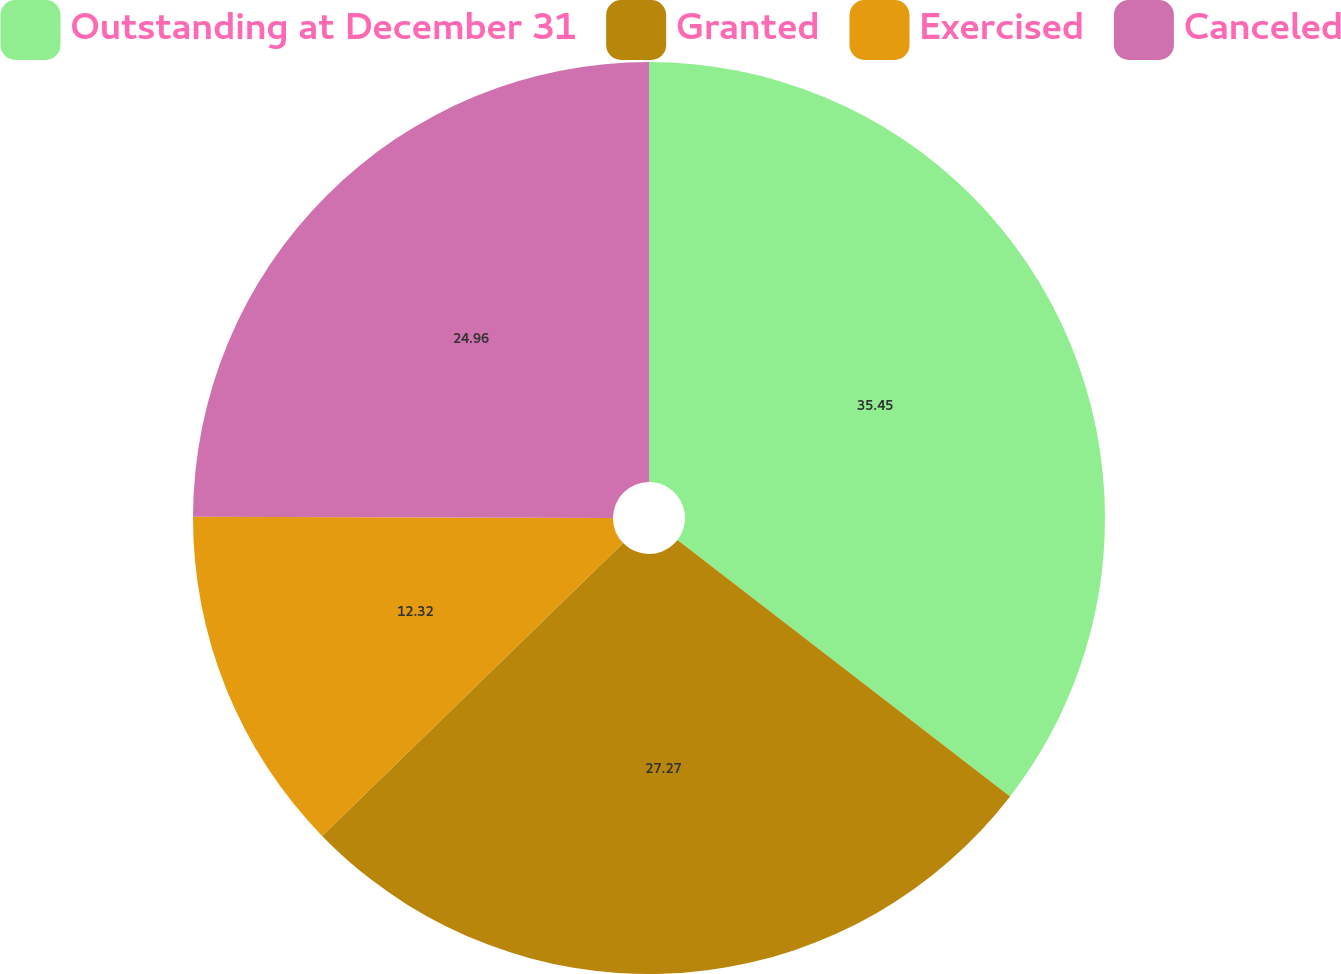Convert chart to OTSL. <chart><loc_0><loc_0><loc_500><loc_500><pie_chart><fcel>Outstanding at December 31<fcel>Granted<fcel>Exercised<fcel>Canceled<nl><fcel>35.46%<fcel>27.27%<fcel>12.32%<fcel>24.96%<nl></chart> 